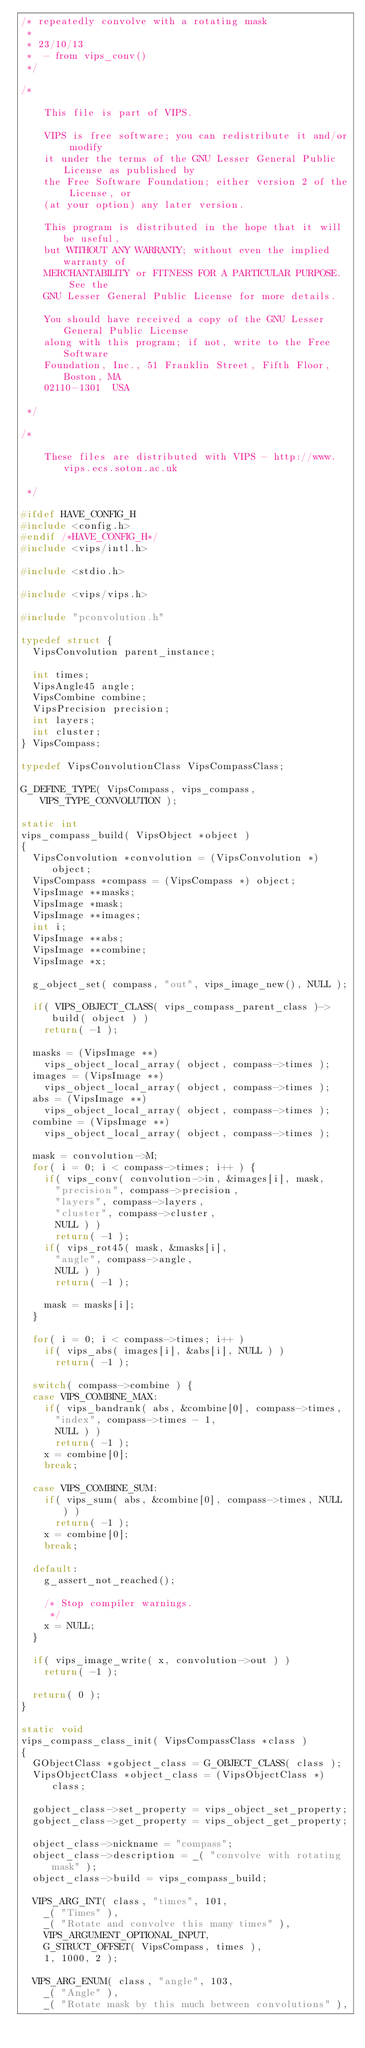<code> <loc_0><loc_0><loc_500><loc_500><_C_>/* repeatedly convolve with a rotating mask
 *
 * 23/10/13	
 * 	- from vips_conv()
 */

/*

    This file is part of VIPS.
    
    VIPS is free software; you can redistribute it and/or modify
    it under the terms of the GNU Lesser General Public License as published by
    the Free Software Foundation; either version 2 of the License, or
    (at your option) any later version.

    This program is distributed in the hope that it will be useful,
    but WITHOUT ANY WARRANTY; without even the implied warranty of
    MERCHANTABILITY or FITNESS FOR A PARTICULAR PURPOSE.  See the
    GNU Lesser General Public License for more details.

    You should have received a copy of the GNU Lesser General Public License
    along with this program; if not, write to the Free Software
    Foundation, Inc., 51 Franklin Street, Fifth Floor, Boston, MA
    02110-1301  USA

 */

/*

    These files are distributed with VIPS - http://www.vips.ecs.soton.ac.uk

 */

#ifdef HAVE_CONFIG_H
#include <config.h>
#endif /*HAVE_CONFIG_H*/
#include <vips/intl.h>

#include <stdio.h>

#include <vips/vips.h>

#include "pconvolution.h"

typedef struct {
	VipsConvolution parent_instance;

	int times; 
	VipsAngle45 angle; 
	VipsCombine combine; 
	VipsPrecision precision; 
	int layers; 
	int cluster; 
} VipsCompass;

typedef VipsConvolutionClass VipsCompassClass;

G_DEFINE_TYPE( VipsCompass, vips_compass, VIPS_TYPE_CONVOLUTION );

static int
vips_compass_build( VipsObject *object )
{
	VipsConvolution *convolution = (VipsConvolution *) object;
	VipsCompass *compass = (VipsCompass *) object;
	VipsImage **masks;
	VipsImage *mask;
	VipsImage **images;
	int i; 
	VipsImage **abs;
	VipsImage **combine;
	VipsImage *x;

	g_object_set( compass, "out", vips_image_new(), NULL ); 

	if( VIPS_OBJECT_CLASS( vips_compass_parent_class )->build( object ) )
		return( -1 );

	masks = (VipsImage **) 
		vips_object_local_array( object, compass->times );
	images = (VipsImage **) 
		vips_object_local_array( object, compass->times );
	abs = (VipsImage **) 
		vips_object_local_array( object, compass->times );
	combine = (VipsImage **) 
		vips_object_local_array( object, compass->times );

	mask = convolution->M;
	for( i = 0; i < compass->times; i++ ) {
		if( vips_conv( convolution->in, &images[i], mask, 
			"precision", compass->precision,
			"layers", compass->layers,
			"cluster", compass->cluster,
			NULL ) )
			return( -1 ); 
		if( vips_rot45( mask, &masks[i],
			"angle", compass->angle,
			NULL ) )
			return( -1 ); 

		mask = masks[i];
	}

	for( i = 0; i < compass->times; i++ )
		if( vips_abs( images[i], &abs[i], NULL ) )
			return( -1 ); 

	switch( compass->combine ) { 
	case VIPS_COMBINE_MAX:
		if( vips_bandrank( abs, &combine[0], compass->times,
			"index", compass->times - 1,
			NULL ) )
			return( -1 ); 
		x = combine[0];
		break;

	case VIPS_COMBINE_SUM:
		if( vips_sum( abs, &combine[0], compass->times, NULL ) )
			return( -1 );
		x = combine[0];
		break;

	default:
		g_assert_not_reached();

		/* Stop compiler warnings.
		 */
		x = NULL;
	}

	if( vips_image_write( x, convolution->out ) )
		return( -1 ); 

	return( 0 );
}

static void
vips_compass_class_init( VipsCompassClass *class )
{
	GObjectClass *gobject_class = G_OBJECT_CLASS( class );
	VipsObjectClass *object_class = (VipsObjectClass *) class;

	gobject_class->set_property = vips_object_set_property;
	gobject_class->get_property = vips_object_get_property;

	object_class->nickname = "compass";
	object_class->description = _( "convolve with rotating mask" );
	object_class->build = vips_compass_build;

	VIPS_ARG_INT( class, "times", 101, 
		_( "Times" ), 
		_( "Rotate and convolve this many times" ),
		VIPS_ARGUMENT_OPTIONAL_INPUT, 
		G_STRUCT_OFFSET( VipsCompass, times ), 
		1, 1000, 2 ); 

	VIPS_ARG_ENUM( class, "angle", 103, 
		_( "Angle" ), 
		_( "Rotate mask by this much between convolutions" ),</code> 